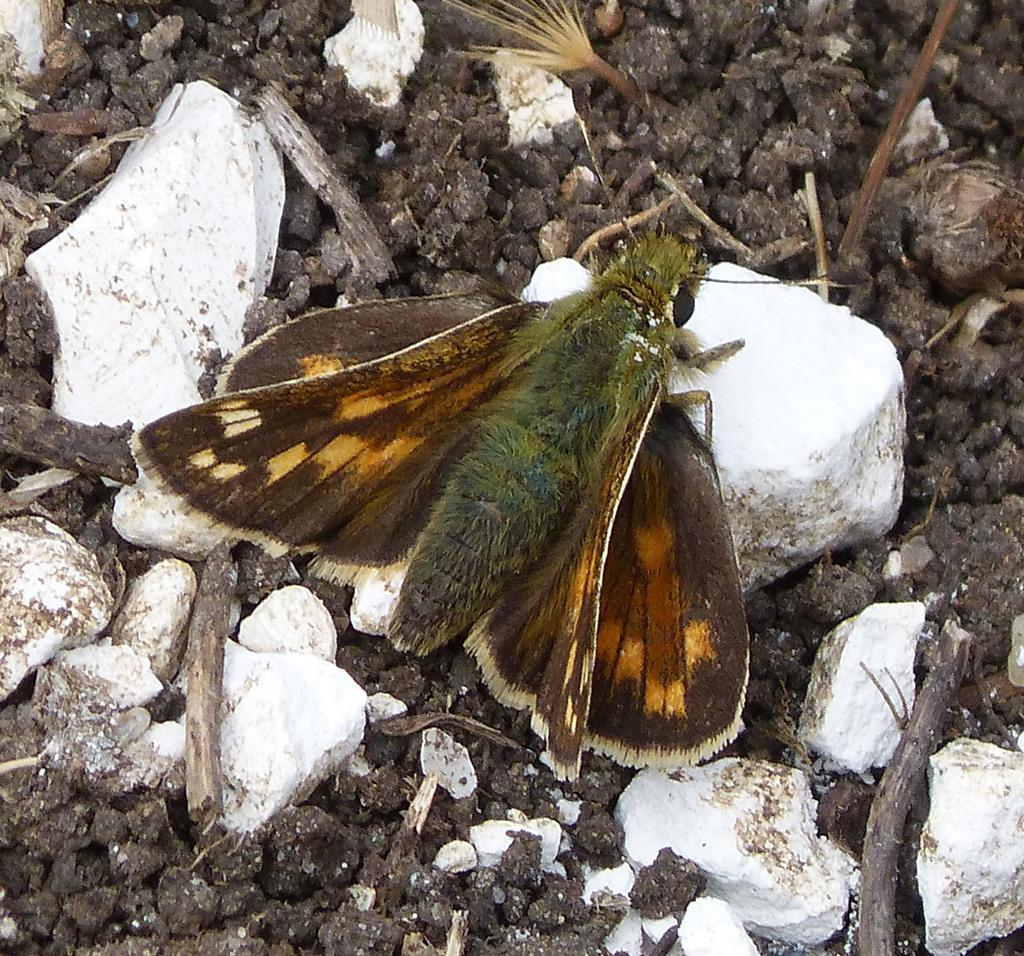What type of insect is in the image? There is a brown color butterfly in the image. What is the butterfly sitting on? The butterfly is sitting on white pebble stones. What type of boundary can be seen in the image? There is no boundary present in the image; it features a brown color butterfly sitting on white pebble stones. What type of knife is being used by the butterfly in the image? There is no knife present in the image; it features a brown color butterfly sitting on white pebble stones. 